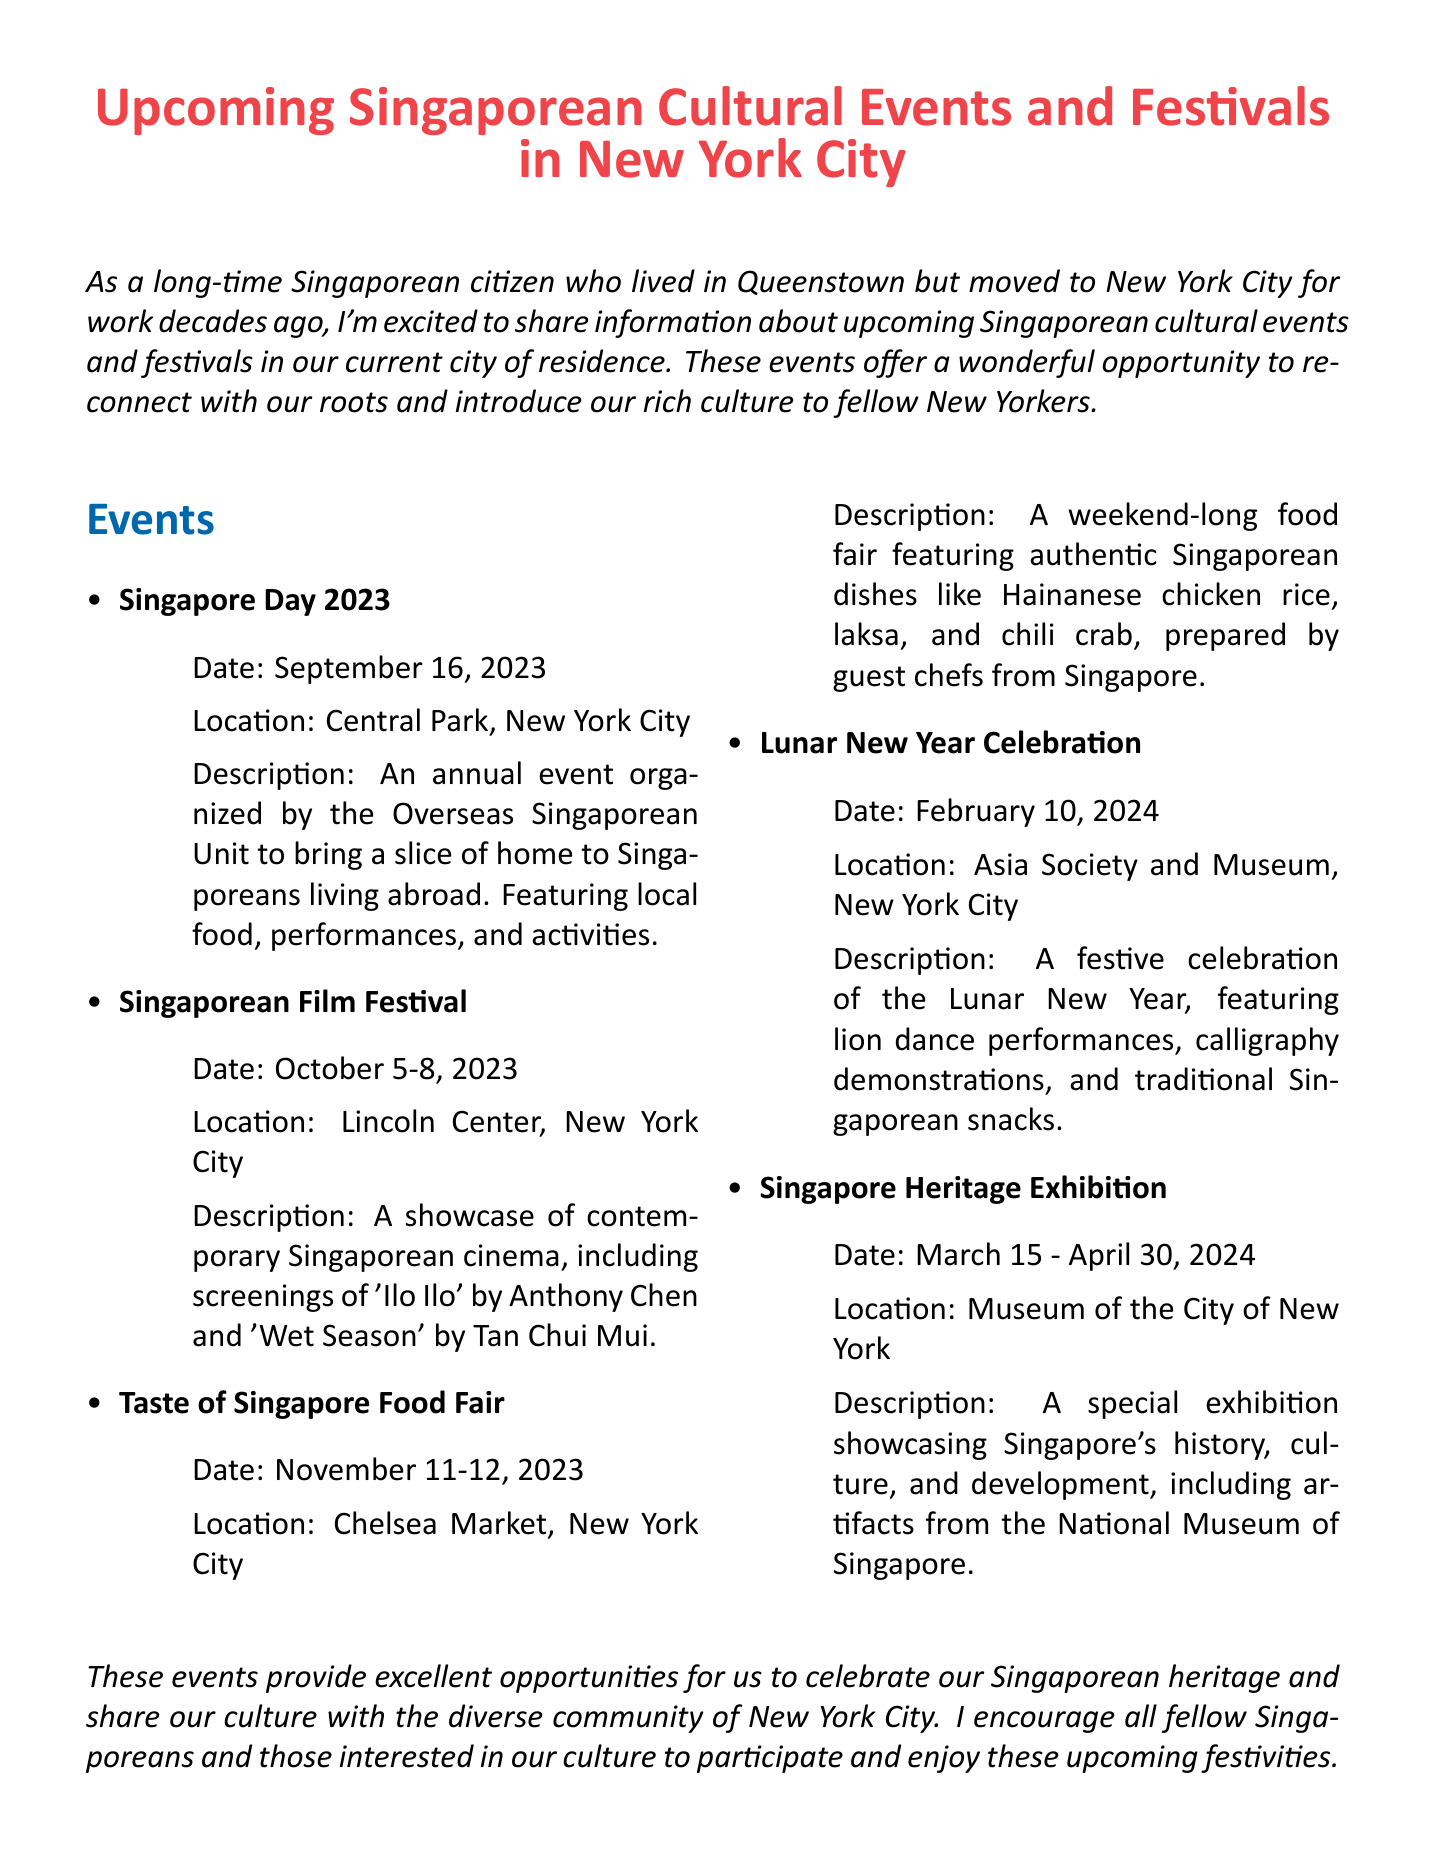What is the title of the memo? The title of the memo is explicitly stated at the beginning of the document.
Answer: Upcoming Singaporean Cultural Events and Festivals in New York City When is Singapore Day 2023? The date of Singapore Day 2023 is provided under its description in the events section.
Answer: September 16, 2023 Where will the Singaporean Film Festival take place? The location of the Singaporean Film Festival is mentioned in its details within the events.
Answer: Lincoln Center, New York City What type of event is the Taste of Singapore Food Fair? The description of the Taste of Singapore Food Fair specifies that it is a food-related event featuring authentic dishes.
Answer: Food fair How long will the Singapore Heritage Exhibition last? The duration of the Singapore Heritage Exhibition is given as a date range in the document.
Answer: March 15 - April 30, 2024 Which event features lion dance performances? The event that includes lion dance performances is specified in its description.
Answer: Lunar New Year Celebration What is the main purpose of these events? The conclusion summarizes the intent of the events for Singaporeans in New York City.
Answer: Celebrate Singaporean heritage How many days is the Singaporean Film Festival? The document provides the start and end dates, allowing for calculation of the total duration.
Answer: 4 days Who organizes the Singapore Day event? The memo explicitly states the organizer of Singapore Day in its description.
Answer: Overseas Singaporean Unit 